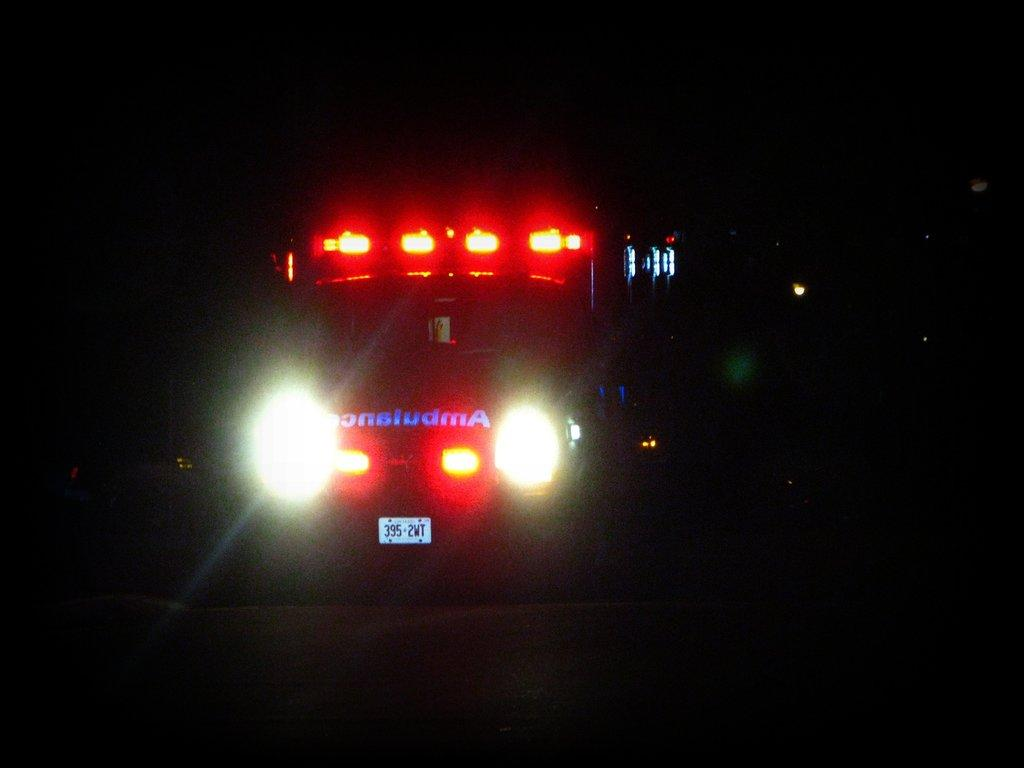What is the main subject of the image? The main subject of the image is a vehicle. What specific features can be seen on the vehicle? The vehicle has lights and a number plate. What is the color of the background in the image? The background of the image is dark. What type of cast can be seen on the vehicle's flesh in the image? There is no cast or flesh present on the vehicle in the image. What amusement park ride is visible in the background of the image? There is no amusement park ride visible in the image; the background is dark. 